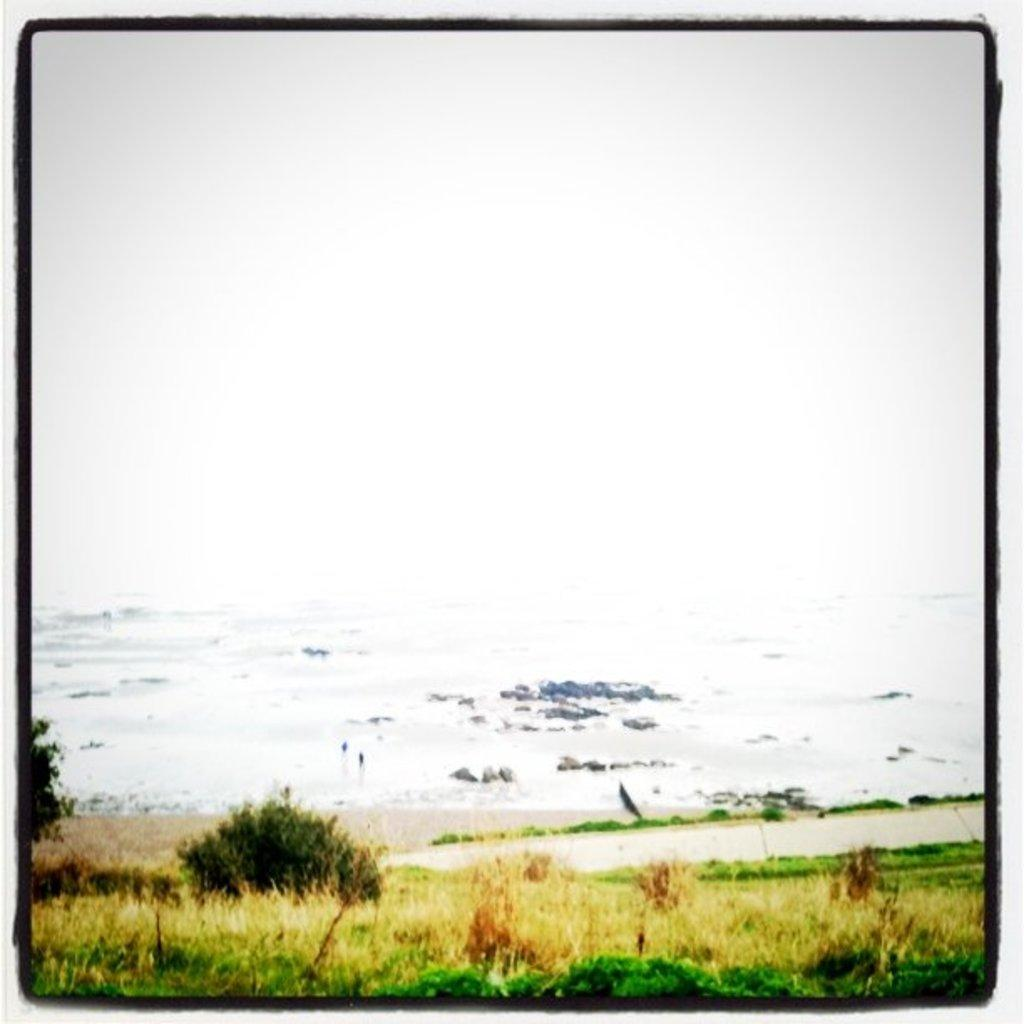What is the main subject of the image? The image contains a painting. What elements are included in the painting? The painting includes grass, plants, water, and stones. What type of magic is being performed with the liquid in the painting? There is no liquid or magic present in the painting; it includes grass, plants, water, and stones. 